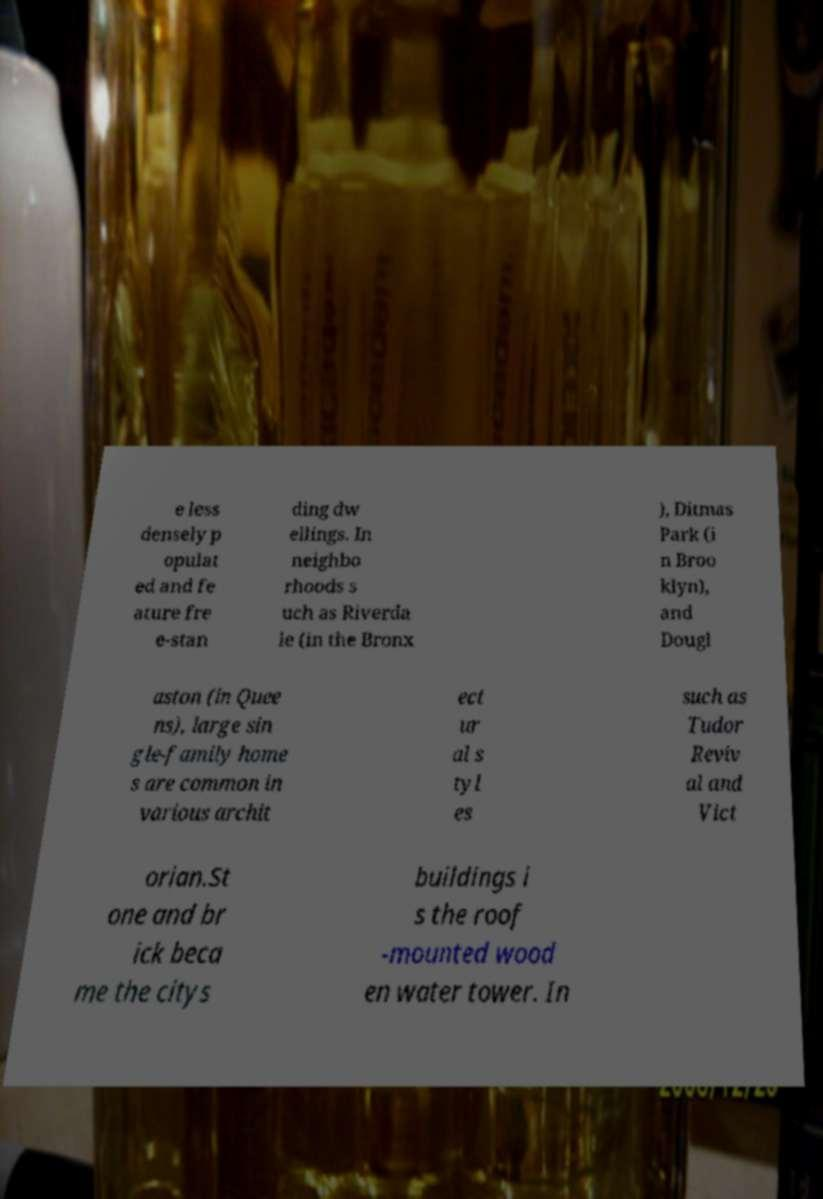Can you read and provide the text displayed in the image?This photo seems to have some interesting text. Can you extract and type it out for me? e less densely p opulat ed and fe ature fre e-stan ding dw ellings. In neighbo rhoods s uch as Riverda le (in the Bronx ), Ditmas Park (i n Broo klyn), and Dougl aston (in Quee ns), large sin gle-family home s are common in various archit ect ur al s tyl es such as Tudor Reviv al and Vict orian.St one and br ick beca me the citys buildings i s the roof -mounted wood en water tower. In 